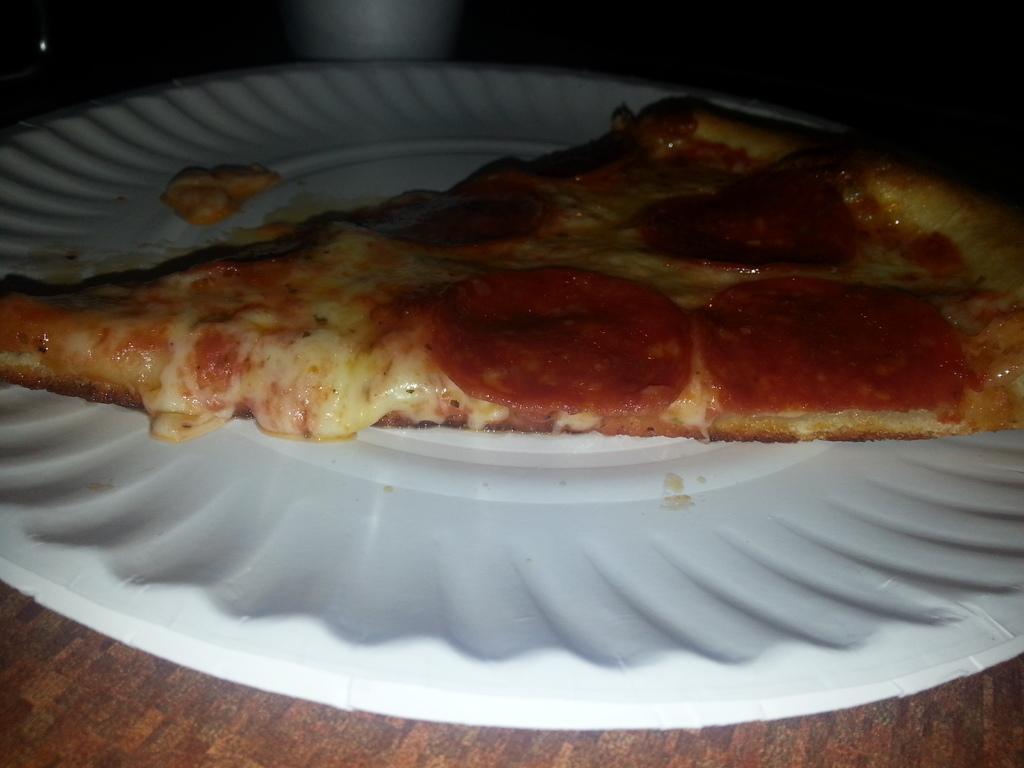Can you describe this image briefly? In this image, we can see some food item on a plate. We can also see a white colored object at the top. 